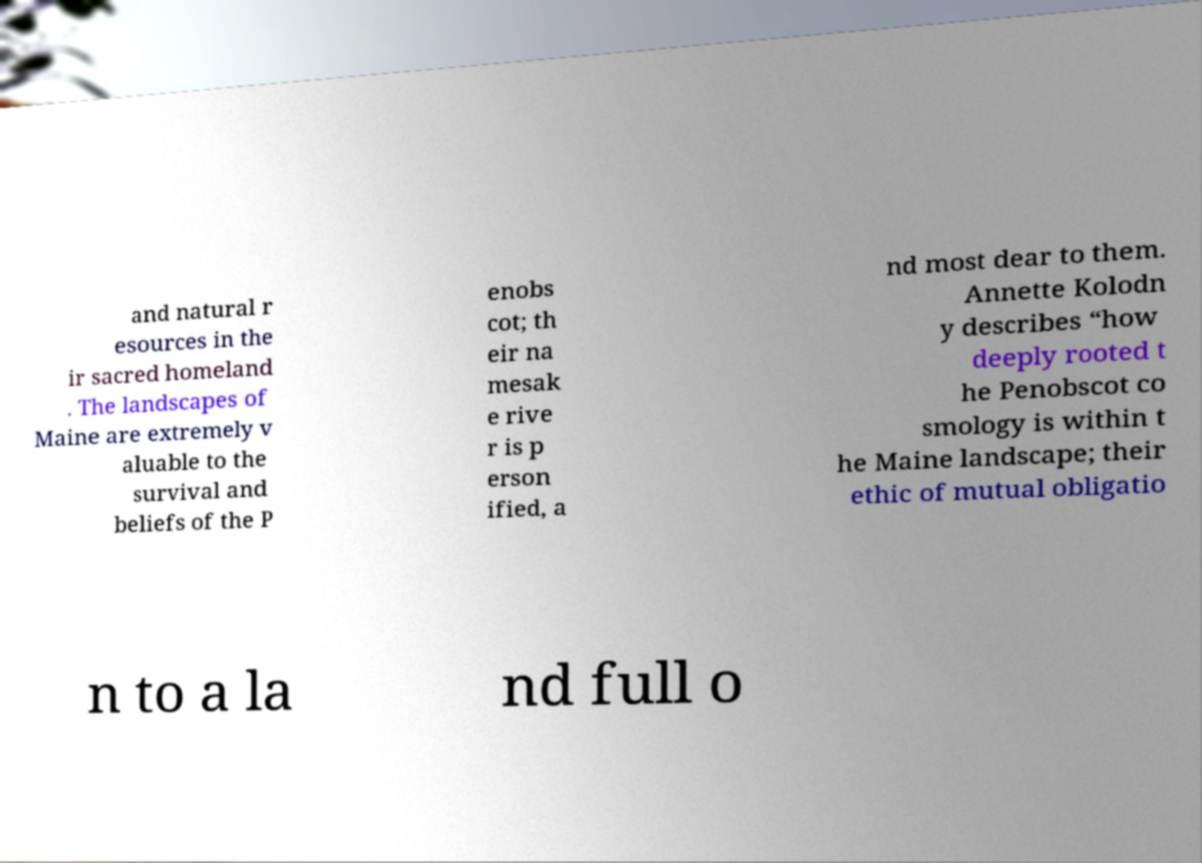What messages or text are displayed in this image? I need them in a readable, typed format. and natural r esources in the ir sacred homeland . The landscapes of Maine are extremely v aluable to the survival and beliefs of the P enobs cot; th eir na mesak e rive r is p erson ified, a nd most dear to them. Annette Kolodn y describes “how deeply rooted t he Penobscot co smology is within t he Maine landscape; their ethic of mutual obligatio n to a la nd full o 